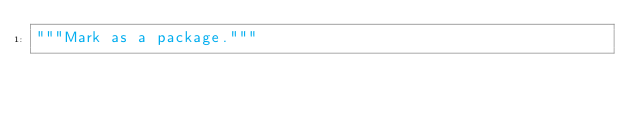Convert code to text. <code><loc_0><loc_0><loc_500><loc_500><_Python_>"""Mark as a package."""
</code> 